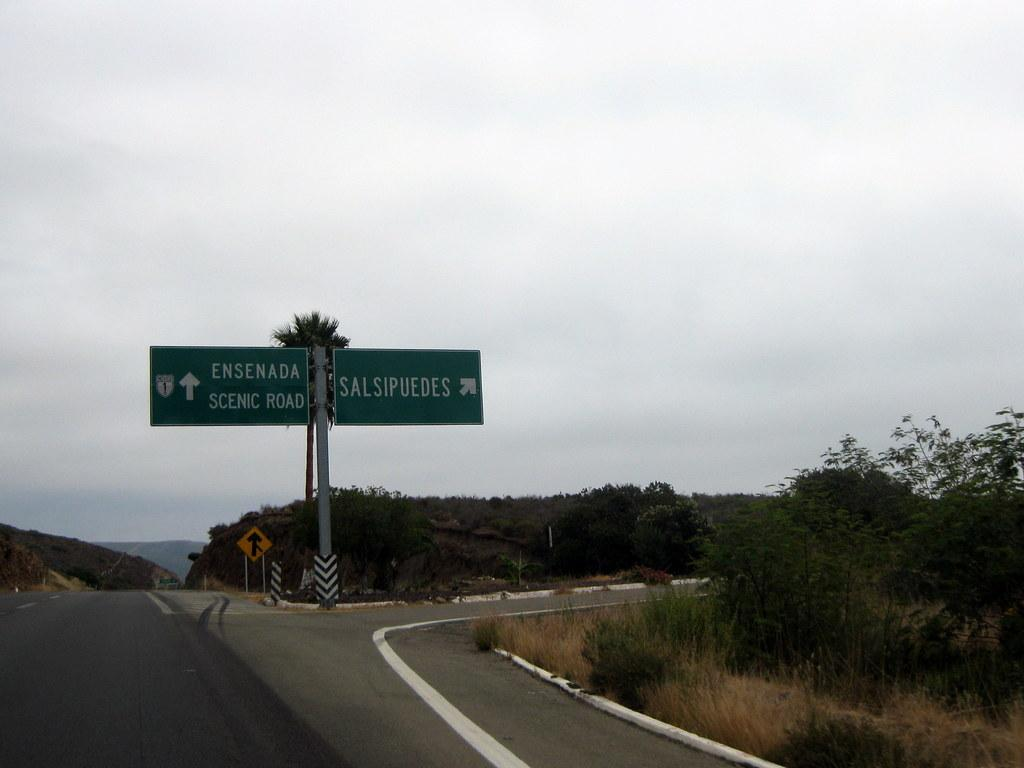What type of natural elements can be seen in the image? There are trees in the image. What type of man-made structures are present in the image? There are roads and name boards on poles in the image. What additional object can be seen in the image related to planning or design? There is a design board on the back in the image. How would you describe the weather condition in the image? The sky is cloudy in the image. Can you tell me how many bags of popcorn are scattered on the ground in the image? There is no mention of popcorn in the image; it features trees, roads, name boards, a design board, and a cloudy sky. Are there any snakes visible in the image? There is no mention of snakes in the image; it features trees, roads, name boards, a design board, and a cloudy sky. 